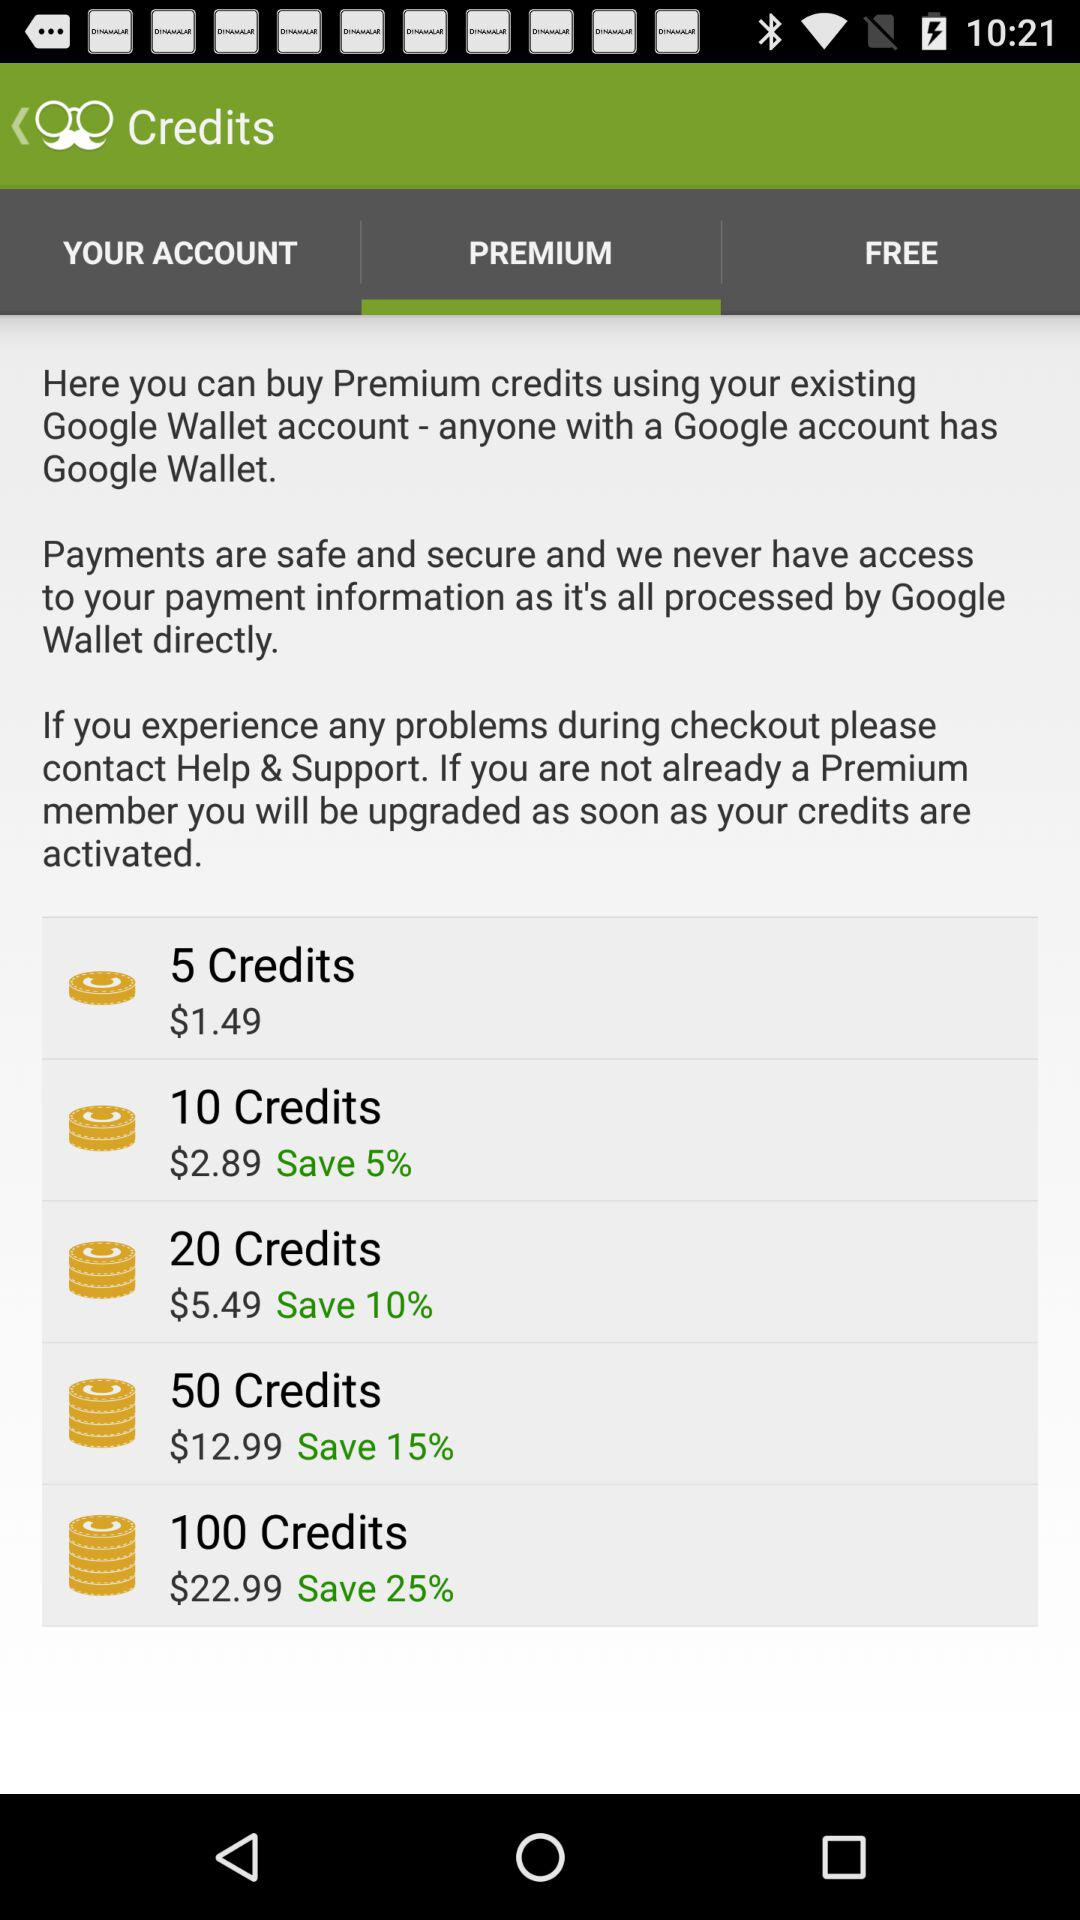How much balance is in 50 credits? The balance is $12.99. 